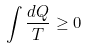Convert formula to latex. <formula><loc_0><loc_0><loc_500><loc_500>\int \frac { d Q } { T } \geq 0</formula> 